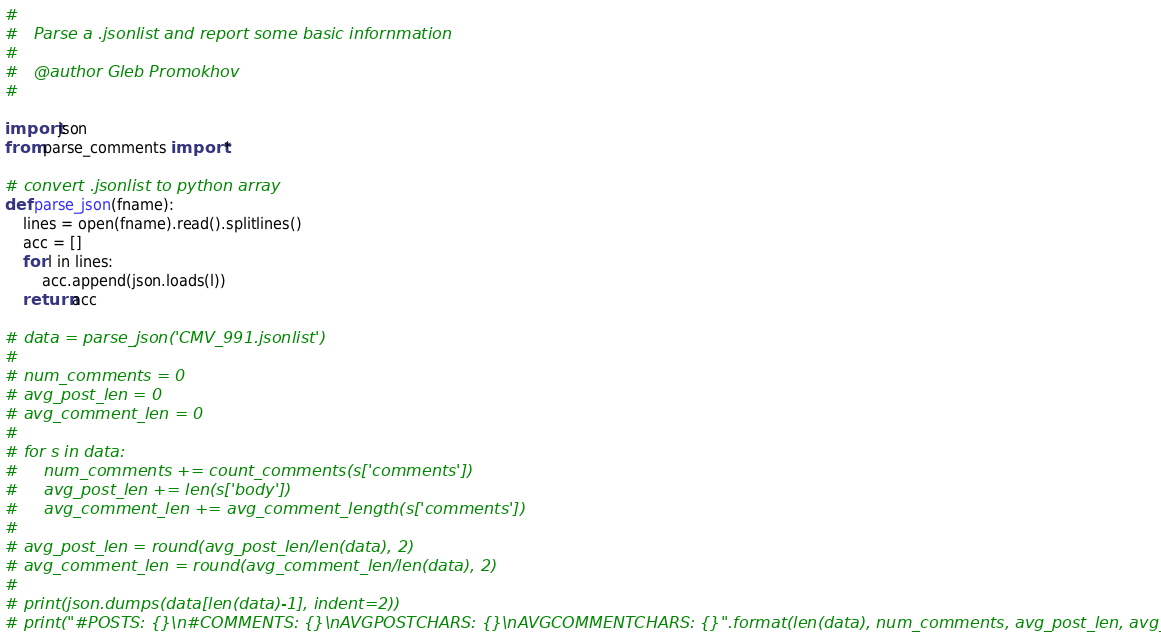<code> <loc_0><loc_0><loc_500><loc_500><_Python_>#
#   Parse a .jsonlist and report some basic infornmation
#
#   @author Gleb Promokhov
#

import json
from parse_comments import *

# convert .jsonlist to python array
def parse_json(fname):
    lines = open(fname).read().splitlines()
    acc = []
    for l in lines:
        acc.append(json.loads(l))
    return acc

# data = parse_json('CMV_991.jsonlist')
#
# num_comments = 0
# avg_post_len = 0
# avg_comment_len = 0
#
# for s in data:
#     num_comments += count_comments(s['comments'])
#     avg_post_len += len(s['body'])
#     avg_comment_len += avg_comment_length(s['comments'])
#
# avg_post_len = round(avg_post_len/len(data), 2)
# avg_comment_len = round(avg_comment_len/len(data), 2)
#
# print(json.dumps(data[len(data)-1], indent=2))
# print("#POSTS: {}\n#COMMENTS: {}\nAVGPOSTCHARS: {}\nAVGCOMMENTCHARS: {}".format(len(data), num_comments, avg_post_len, avg_comment_len))
</code> 